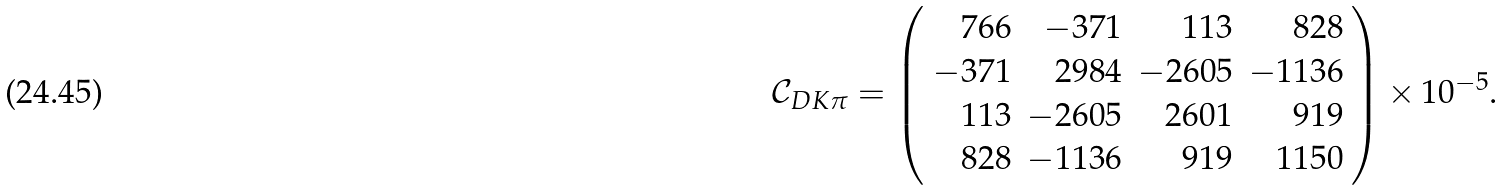Convert formula to latex. <formula><loc_0><loc_0><loc_500><loc_500>\mathcal { C } _ { D K \pi } = \left ( \begin{array} { r r r r } 7 6 6 & - 3 7 1 & 1 1 3 & 8 2 8 \\ - 3 7 1 & 2 9 8 4 & - 2 6 0 5 & - 1 1 3 6 \\ 1 1 3 & - 2 6 0 5 & 2 6 0 1 & 9 1 9 \\ 8 2 8 & - 1 1 3 6 & 9 1 9 & 1 1 5 0 \\ \end{array} \right ) \times 1 0 ^ { - 5 } .</formula> 